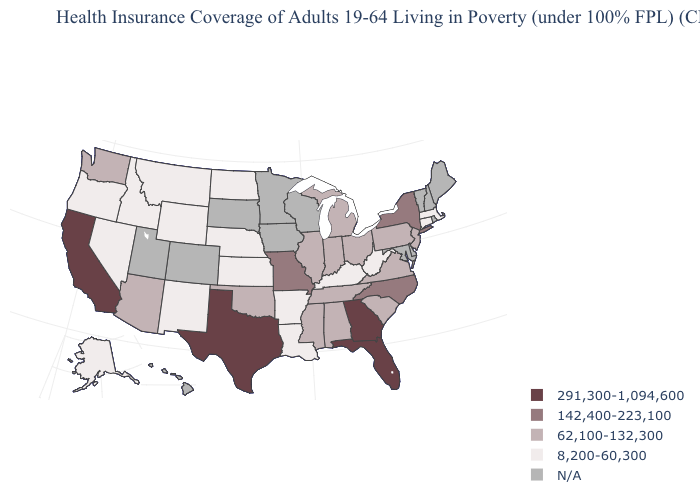What is the value of South Carolina?
Be succinct. 62,100-132,300. How many symbols are there in the legend?
Write a very short answer. 5. What is the highest value in the MidWest ?
Write a very short answer. 142,400-223,100. What is the value of California?
Quick response, please. 291,300-1,094,600. What is the value of Vermont?
Concise answer only. N/A. Name the states that have a value in the range 291,300-1,094,600?
Quick response, please. California, Florida, Georgia, Texas. What is the value of Minnesota?
Give a very brief answer. N/A. Among the states that border Rhode Island , which have the lowest value?
Quick response, please. Connecticut, Massachusetts. Among the states that border North Carolina , does Tennessee have the lowest value?
Give a very brief answer. Yes. Among the states that border Illinois , does Missouri have the highest value?
Short answer required. Yes. Which states have the highest value in the USA?
Answer briefly. California, Florida, Georgia, Texas. What is the value of Mississippi?
Quick response, please. 62,100-132,300. 